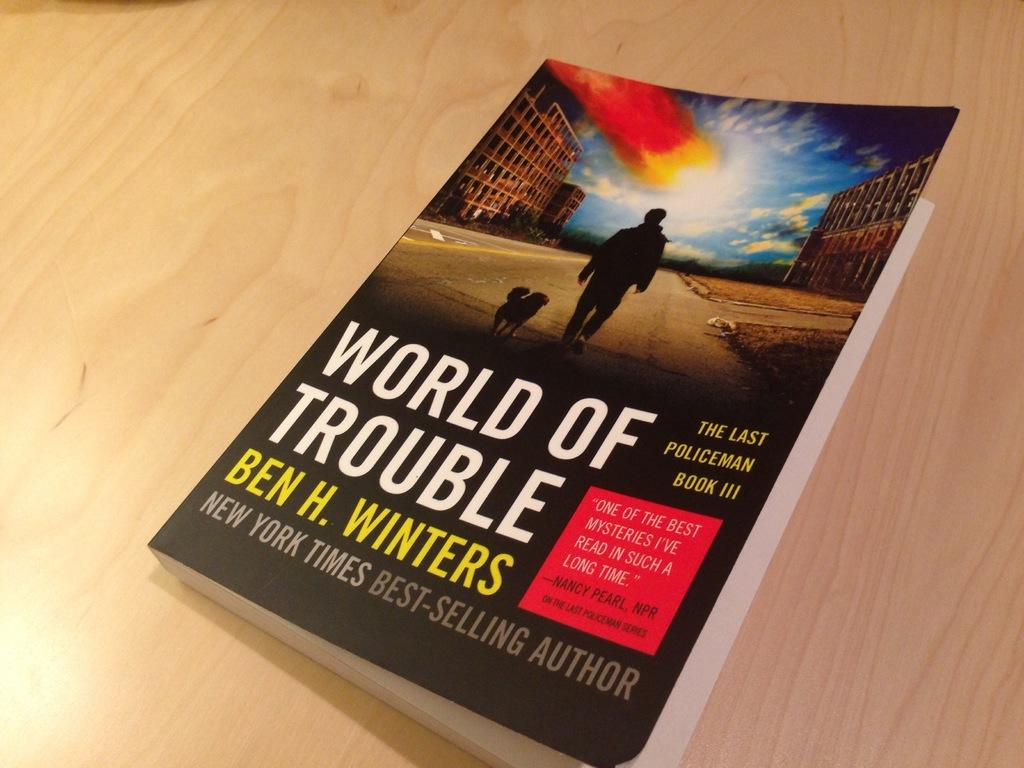What is the main subject of the image? The main subject of the image is a book. What is the title of the book? The title of the book is "World Of Trouble". What image is depicted on the book? There is a picture of a man and a dog on the book. Where is the book located in the image? The book is placed on a table. Can you tell me how many times the bear sneezes in the image? There is no bear present in the image, and therefore no sneezing can be observed. What type of button is featured on the cover of the book? There is no button present on the cover of the book; it features a picture of a man and a dog. 